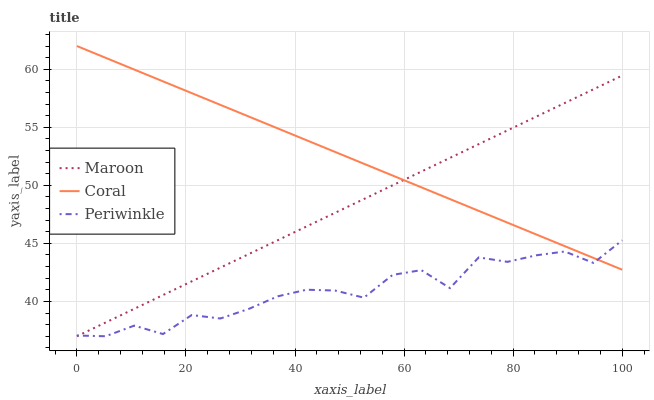Does Periwinkle have the minimum area under the curve?
Answer yes or no. Yes. Does Coral have the maximum area under the curve?
Answer yes or no. Yes. Does Maroon have the minimum area under the curve?
Answer yes or no. No. Does Maroon have the maximum area under the curve?
Answer yes or no. No. Is Coral the smoothest?
Answer yes or no. Yes. Is Periwinkle the roughest?
Answer yes or no. Yes. Is Maroon the smoothest?
Answer yes or no. No. Is Maroon the roughest?
Answer yes or no. No. Does Periwinkle have the lowest value?
Answer yes or no. Yes. Does Coral have the highest value?
Answer yes or no. Yes. Does Maroon have the highest value?
Answer yes or no. No. Does Periwinkle intersect Coral?
Answer yes or no. Yes. Is Periwinkle less than Coral?
Answer yes or no. No. Is Periwinkle greater than Coral?
Answer yes or no. No. 